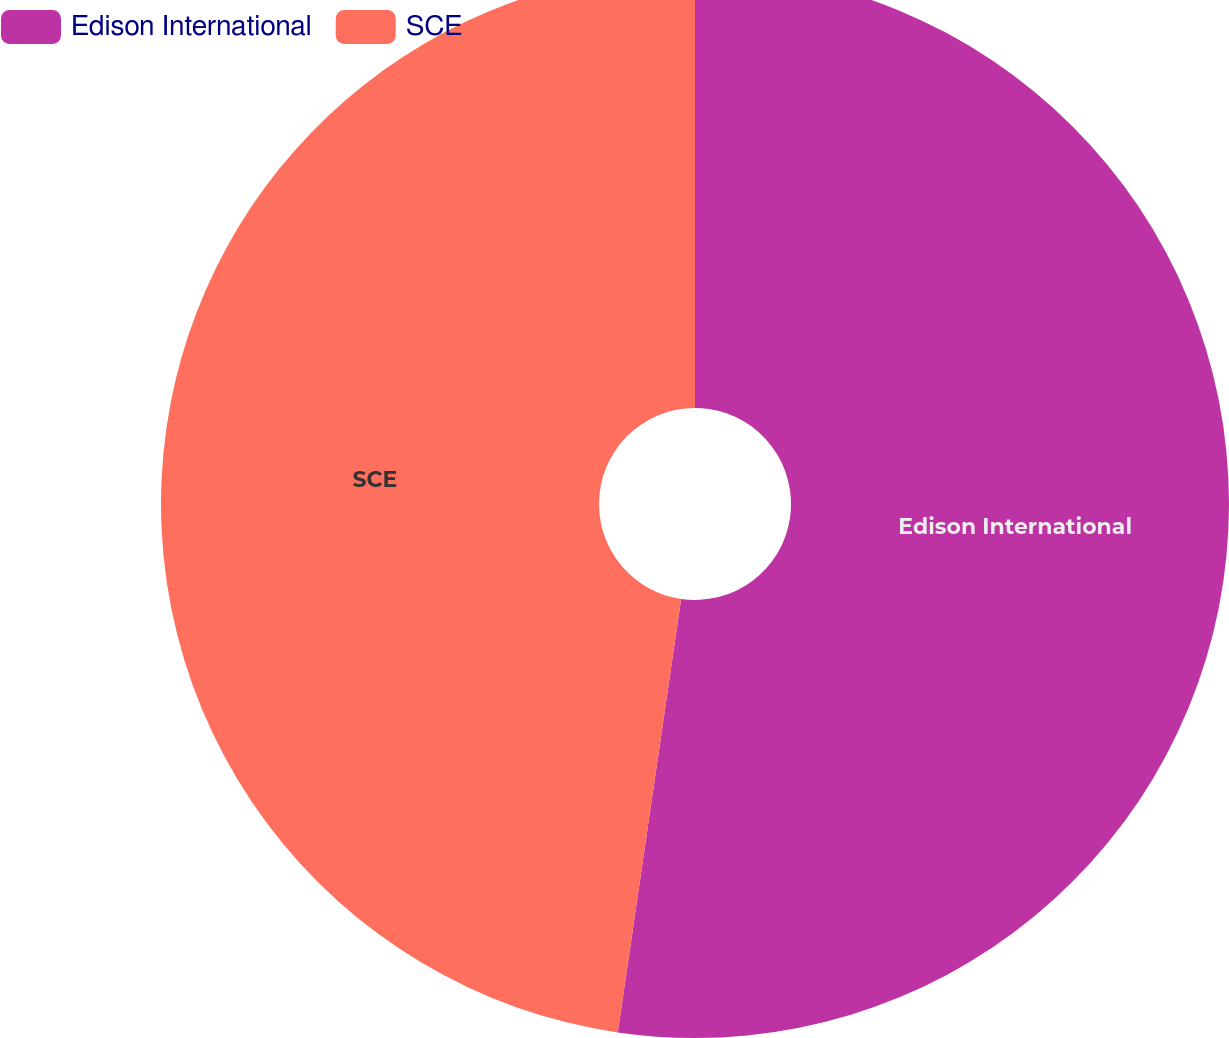<chart> <loc_0><loc_0><loc_500><loc_500><pie_chart><fcel>Edison International<fcel>SCE<nl><fcel>52.31%<fcel>47.69%<nl></chart> 